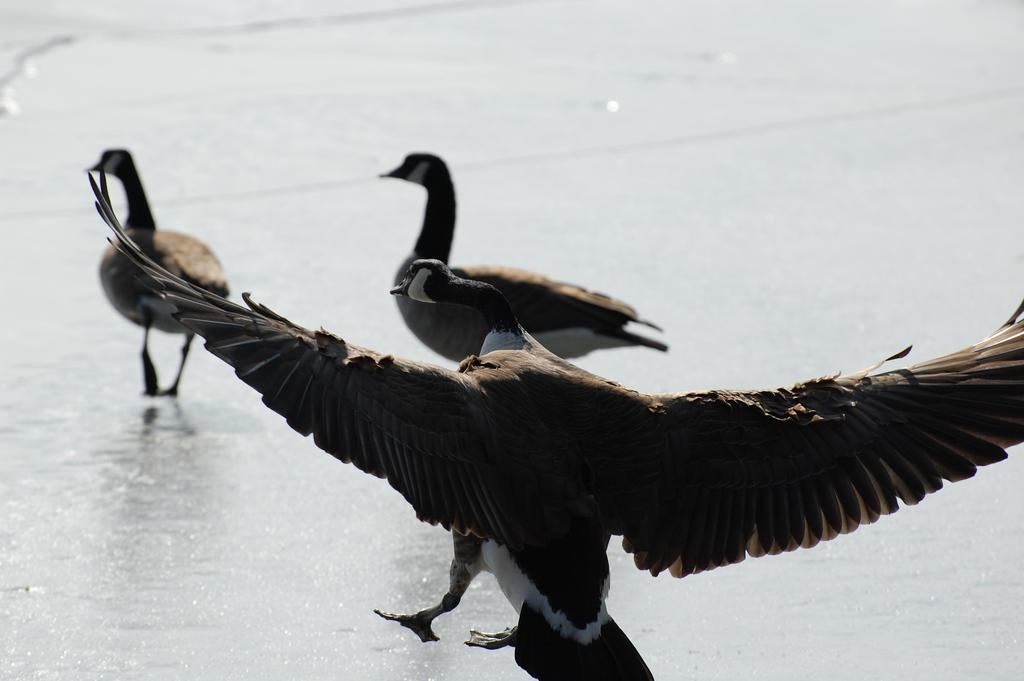What animals can be seen in the image? There are two birds on the ground in the image. What action is being performed by one of the birds in the image? A bird is going to land on the ground in the foreground of the image. What color are the eyes of the giraffe in the image? There is no giraffe present in the image; it features two birds on the ground. 